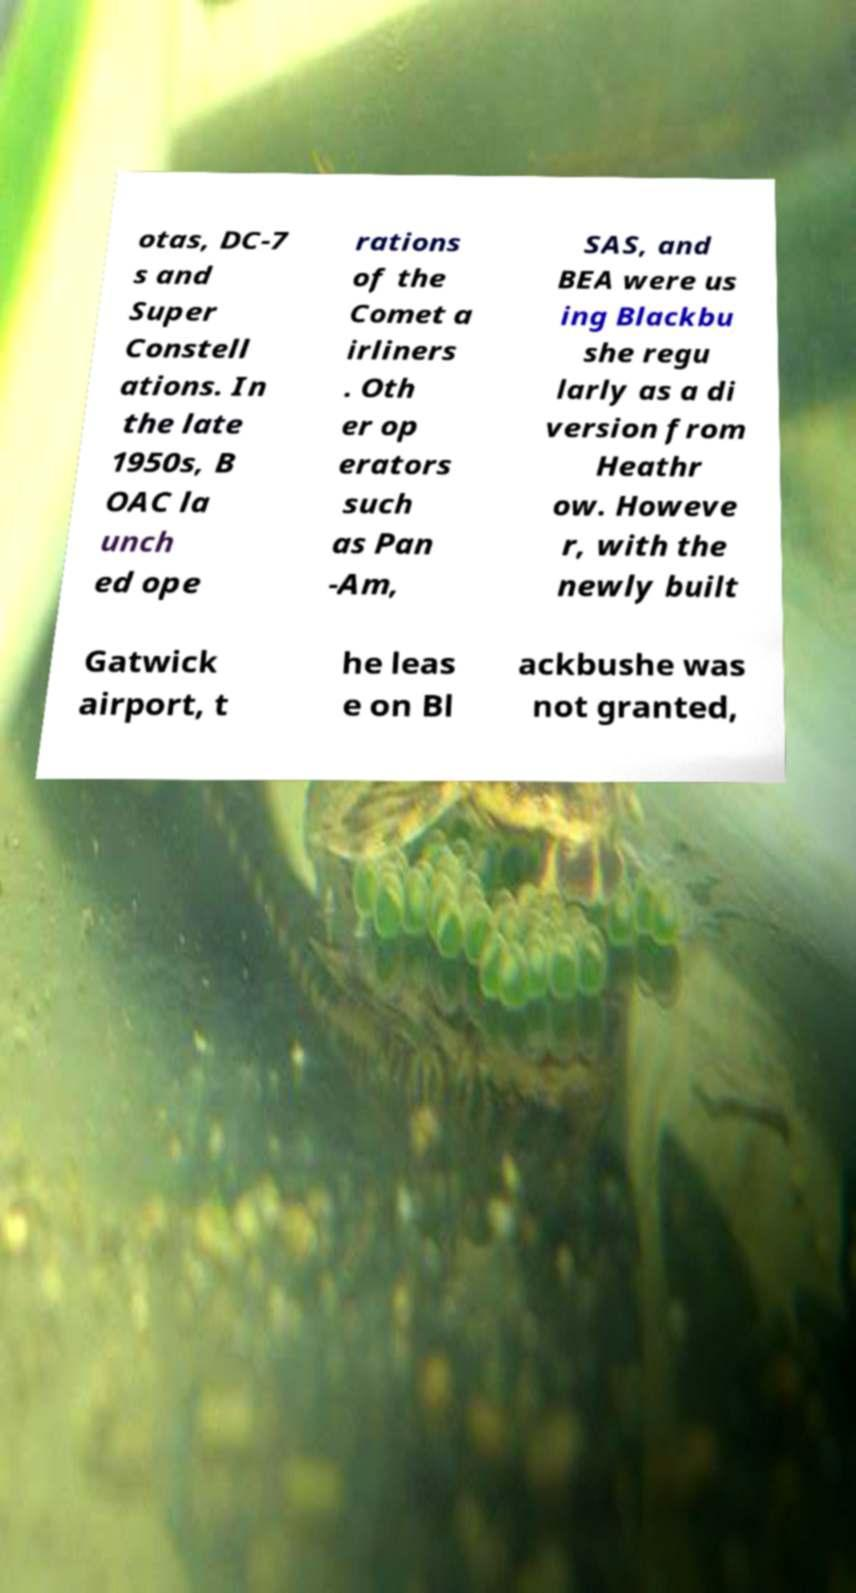What messages or text are displayed in this image? I need them in a readable, typed format. otas, DC-7 s and Super Constell ations. In the late 1950s, B OAC la unch ed ope rations of the Comet a irliners . Oth er op erators such as Pan -Am, SAS, and BEA were us ing Blackbu she regu larly as a di version from Heathr ow. Howeve r, with the newly built Gatwick airport, t he leas e on Bl ackbushe was not granted, 